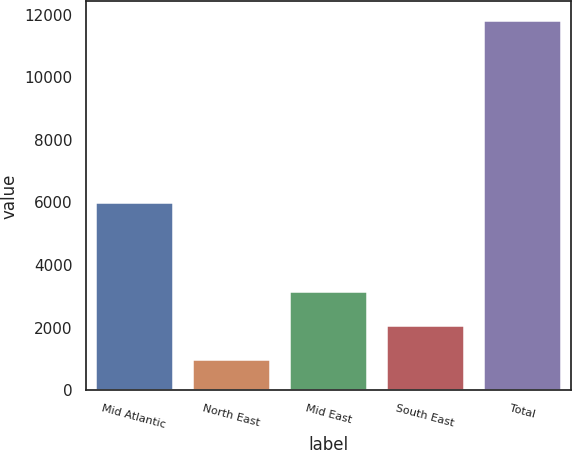Convert chart to OTSL. <chart><loc_0><loc_0><loc_500><loc_500><bar_chart><fcel>Mid Atlantic<fcel>North East<fcel>Mid East<fcel>South East<fcel>Total<nl><fcel>6029<fcel>1013<fcel>3177.2<fcel>2095.1<fcel>11834<nl></chart> 